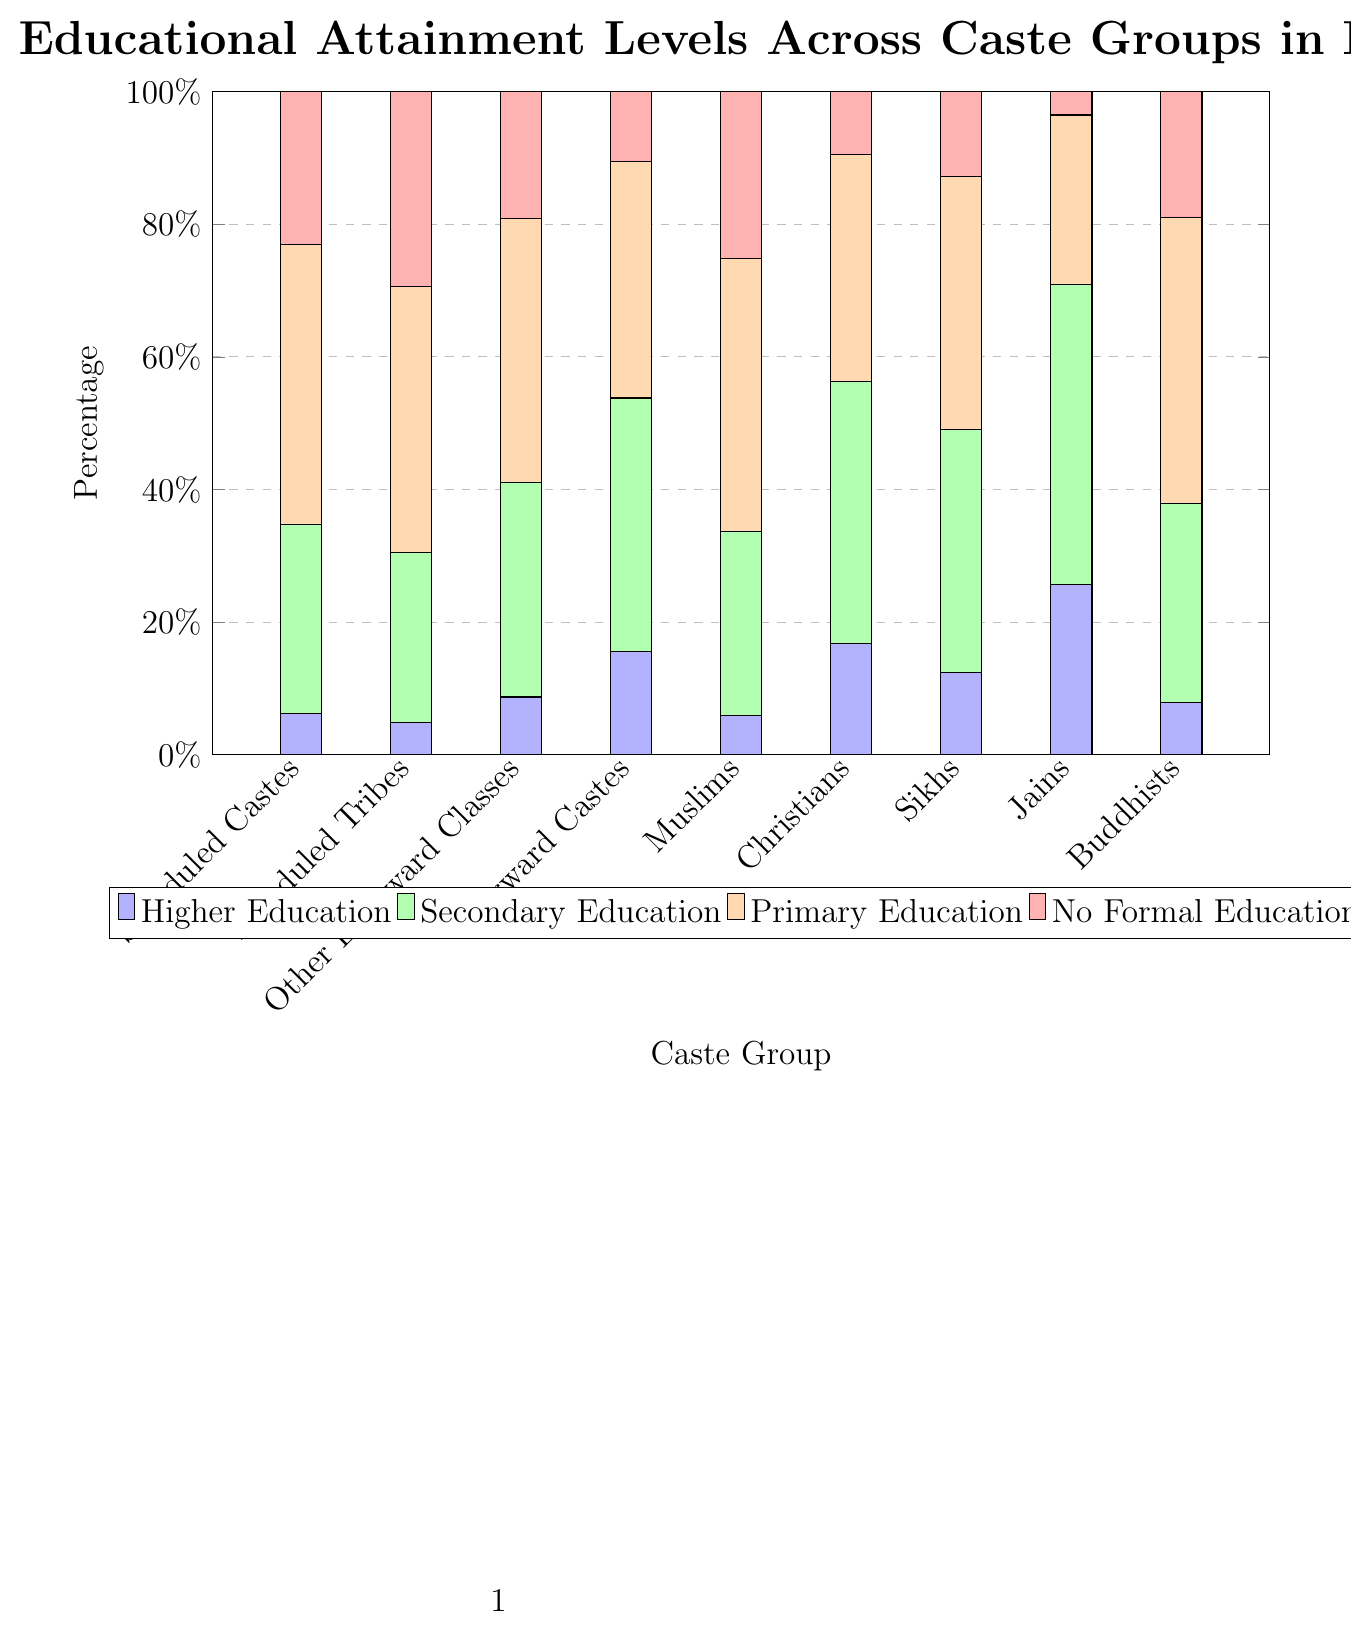Which caste group has the highest percentage of individuals with higher education? By visually inspecting the height of the blue bars, we see that the Jain community has the tallest blue bar. Therefore, Jains have the highest percentage of individuals with higher education.
Answer: Jains Which caste group has the lowest percentage of individuals with no formal education? By checking the height of the red bars, it is evident that the Jain community has the shortest red bar. Hence, Jains have the lowest percentage of individuals with no formal education.
Answer: Jains What is the sum of percentages for secondary education and primary education in the Scheduled Tribes group? Adding the values for secondary education (25.7%) and primary education (40.1%) for the Scheduled Tribes results in 25.7 + 40.1 = 65.8%.
Answer: 65.8% How does the percentage of higher education attainment in Muslims compare to that in Scheduled Castes? The blue bar for Muslims is slightly shorter compared to the blue bar for Scheduled Castes. Thus, Muslims have a slightly lower percentage of higher education attainment than Scheduled Castes.
Answer: Slightly lower Which group has a higher percentage of secondary education, Sikhs or Forward Castes? By comparing the height of the green bars, it is clear that the green bar for Forward Castes is slightly taller than that for Sikhs. Hence, Forward Castes have a higher percentage of secondary education attainment.
Answer: Forward Castes What is the average percentage of higher education across all caste groups? Adding the percentages of higher education across all groups and then dividing by the number of groups: (6.2 + 4.8 + 8.7 + 15.6 + 5.9 + 16.8 + 12.4 + 25.7 + 7.8) / 9 = 11.55%.
Answer: 11.55% Which caste group has the largest difference between primary education and no formal education percentages? Calculating the differences for each group and identifying the largest: Scheduled Castes (42.3 - 23.0 = 19.3), Scheduled Tribes (40.1 - 29.4 = 10.7), Other Backward Classes (39.8 - 19.1 = 20.7), Forward Castes (35.7 - 10.5 = 25.2), Muslims (41.2 - 25.1 = 16.1), Christians (34.2 - 9.5 = 24.7), Sikhs (38.1 - 12.8 = 25.3), Jains (25.6 - 3.5 = 22.1), Buddhists (43.2 - 18.9 = 24.3). Sikhs have the largest difference, which is 25.3%.
Answer: Sikhs What is the combined percentage of primary and secondary education for Christians? Adding the values for secondary education (39.5%) and primary education (34.2%) gives us 39.5 + 34.2 = 73.7%.
Answer: 73.7% Among Buddhists and Muslims, which group has a higher total percentage for secondary and higher education combined? Adding the percentages for Buddhists (30.1% + 7.8% = 37.9%) and Muslims (27.8% + 5.9% = 33.7%) shows that Buddhists have a higher combined percentage.
Answer: Buddhists 